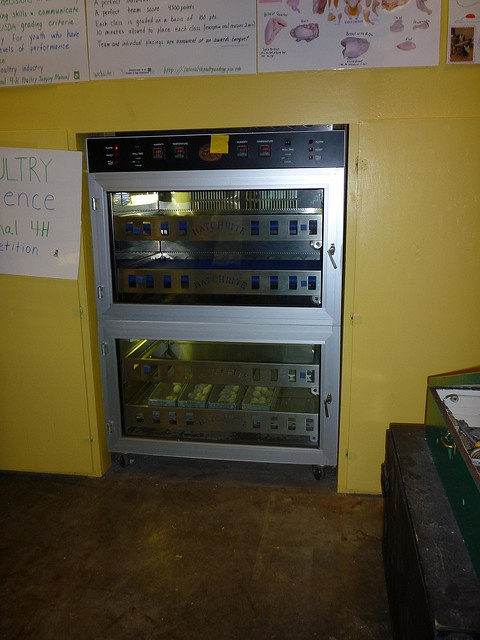Describe the objects in this image and their specific colors. I can see a oven in gray, black, darkgray, and white tones in this image. 